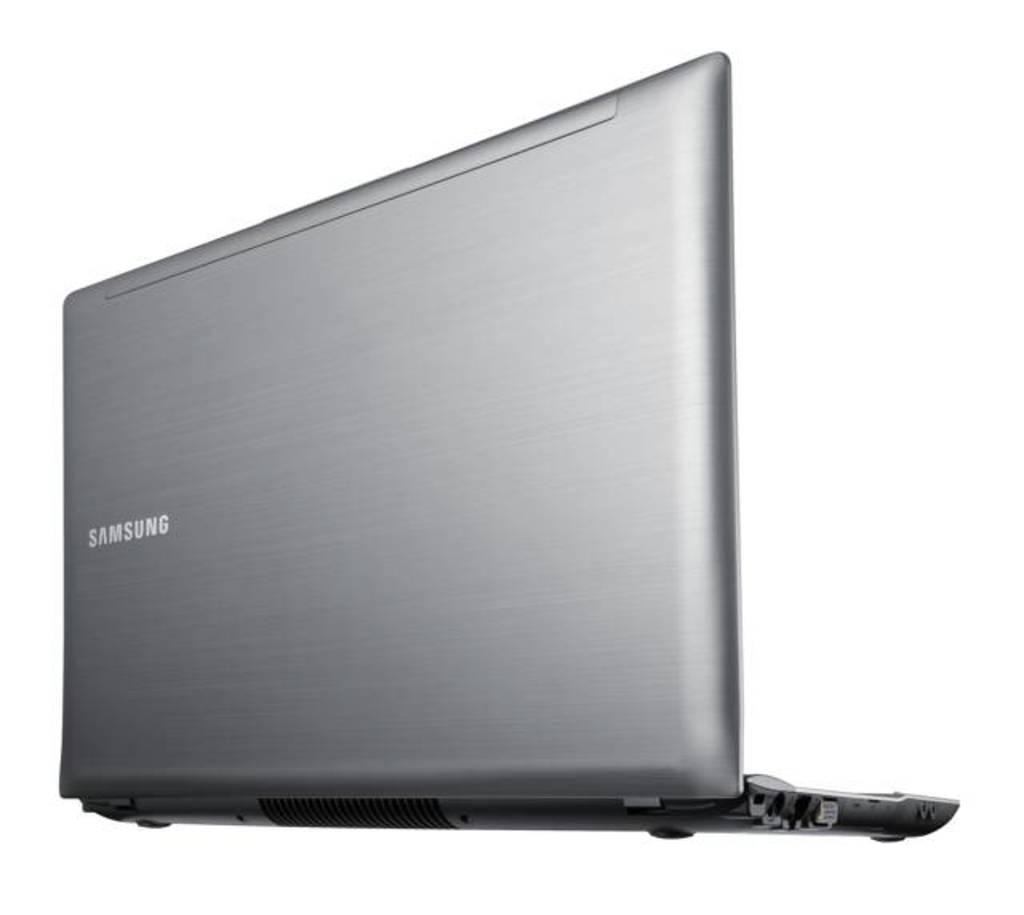<image>
Give a short and clear explanation of the subsequent image. the back of a lap top computer reading Samsung 